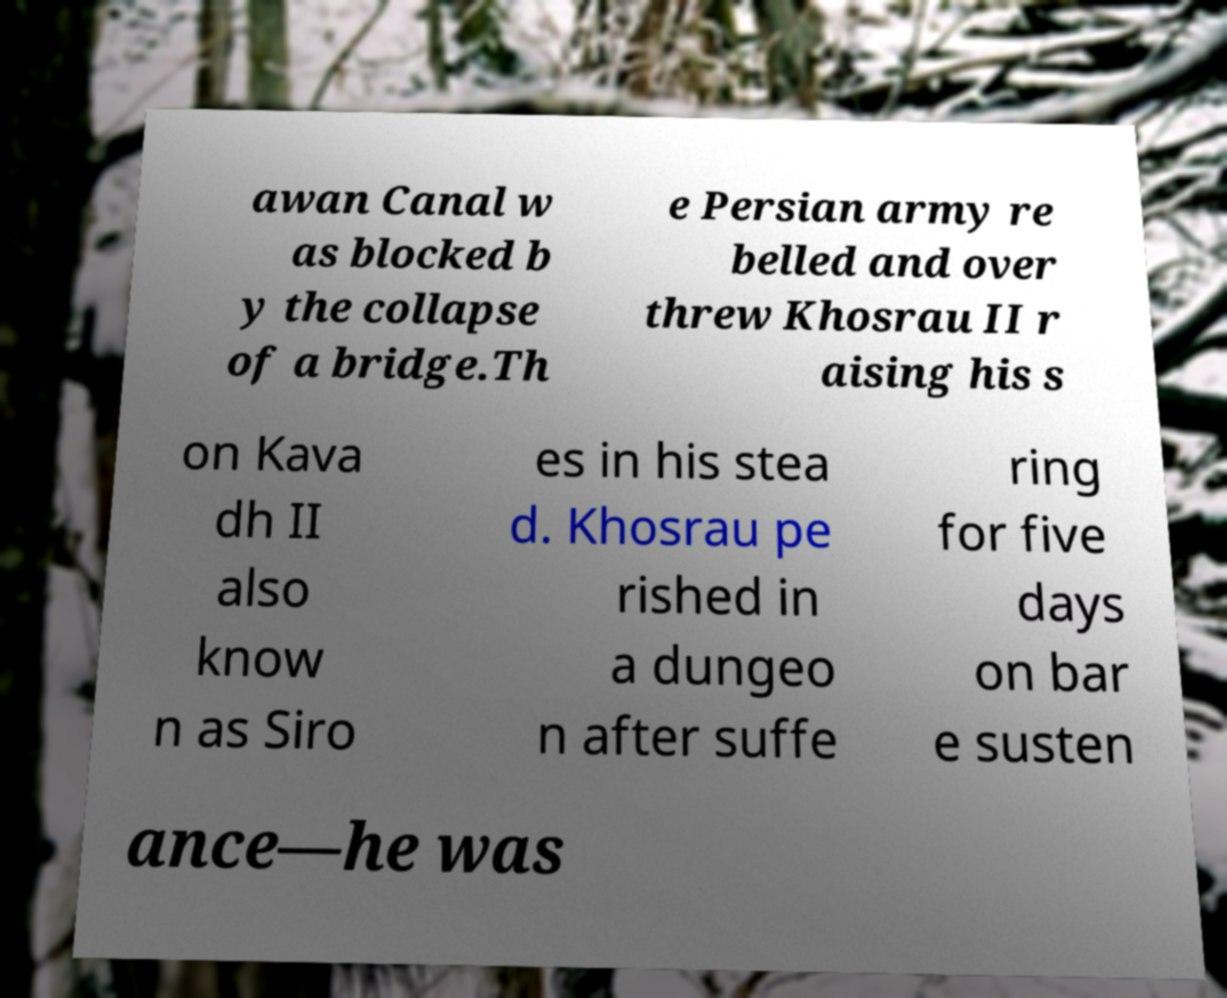Please read and relay the text visible in this image. What does it say? awan Canal w as blocked b y the collapse of a bridge.Th e Persian army re belled and over threw Khosrau II r aising his s on Kava dh II also know n as Siro es in his stea d. Khosrau pe rished in a dungeo n after suffe ring for five days on bar e susten ance—he was 